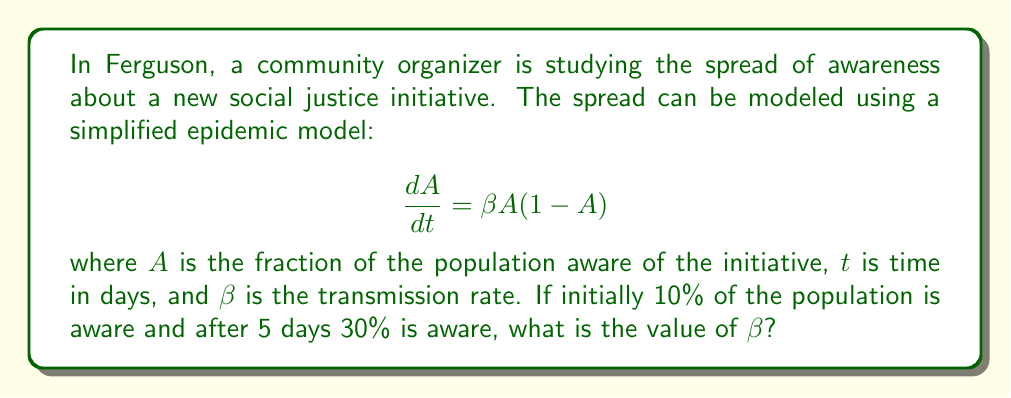Teach me how to tackle this problem. To solve this problem, we need to use the given differential equation and the initial and final conditions. Let's approach this step-by-step:

1) The differential equation is given as:

   $$ \frac{dA}{dt} = \beta A(1-A) $$

2) This is a separable differential equation. We can solve it by separating variables and integrating:

   $$ \int \frac{dA}{A(1-A)} = \int \beta dt $$

3) The left side can be integrated using partial fractions:

   $$ \int (\frac{1}{A} + \frac{1}{1-A}) dA = \beta t + C $$

4) Integrating both sides:

   $$ \ln|\frac{A}{1-A}| = \beta t + C $$

5) Solving for A:

   $$ A = \frac{1}{1 + e^{-(\beta t + C)}} $$

6) Now, let's use the initial condition. At t = 0, A = 0.1:

   $$ 0.1 = \frac{1}{1 + e^{-C}} $$

   Solving this, we get: $C = \ln(9)$

7) Substituting this back into our solution:

   $$ A = \frac{1}{1 + 9e^{-\beta t}} $$

8) Now, we can use the second condition. At t = 5, A = 0.3:

   $$ 0.3 = \frac{1}{1 + 9e^{-5\beta}} $$

9) Solving this equation for $\beta$:

   $$ 1 + 9e^{-5\beta} = \frac{1}{0.3} $$
   $$ 9e^{-5\beta} = \frac{10}{3} - 1 = \frac{7}{3} $$
   $$ e^{-5\beta} = \frac{7}{27} $$
   $$ -5\beta = \ln(\frac{7}{27}) $$
   $$ \beta = -\frac{1}{5}\ln(\frac{7}{27}) = \frac{1}{5}\ln(\frac{27}{7}) $$
Answer: $\beta = \frac{1}{5}\ln(\frac{27}{7}) \approx 0.2724$ per day 